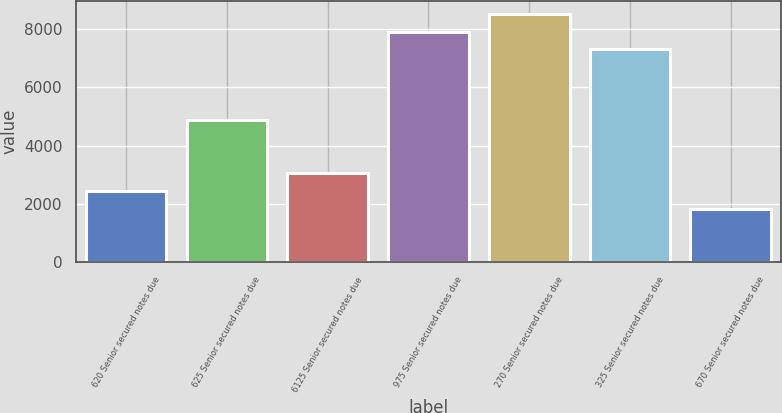Convert chart. <chart><loc_0><loc_0><loc_500><loc_500><bar_chart><fcel>620 Senior secured notes due<fcel>625 Senior secured notes due<fcel>6125 Senior secured notes due<fcel>975 Senior secured notes due<fcel>270 Senior secured notes due<fcel>325 Senior secured notes due<fcel>670 Senior secured notes due<nl><fcel>2437<fcel>4869<fcel>3045<fcel>7909<fcel>8517<fcel>7301<fcel>1829<nl></chart> 